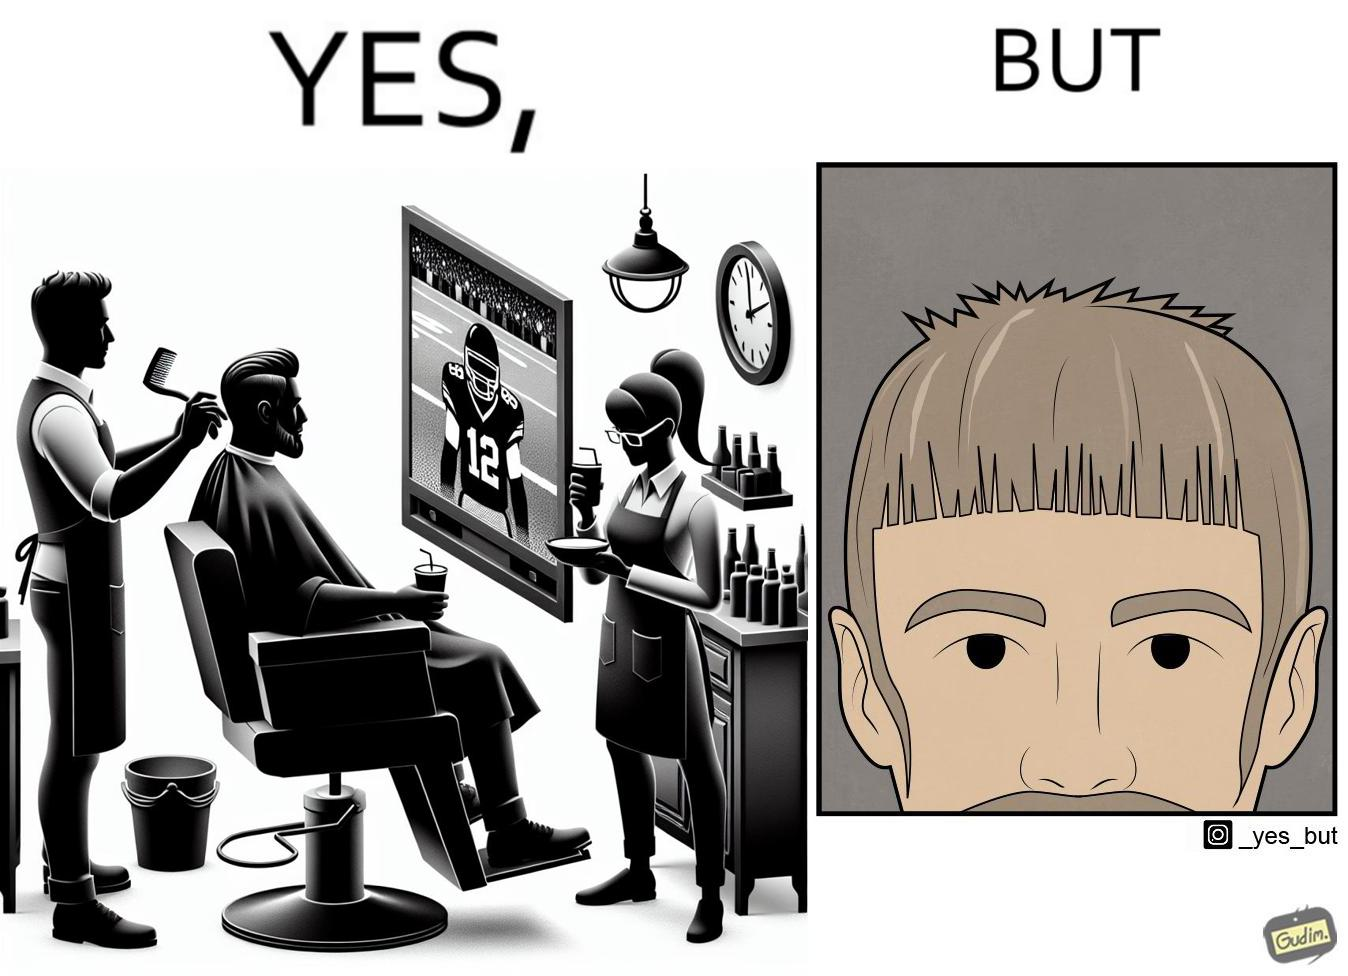Describe the content of this image. The image is ironic, because the sole purpose of the person was to get a hair cut but he became so much engrossed in the game that the barber wasn't able to cut his hairs properly. and even the saloon is providing so many facilities but they don't have a good hairdresser 